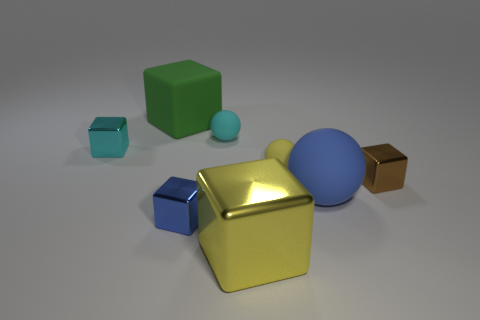Add 2 green cubes. How many objects exist? 10 Subtract all tiny matte balls. How many balls are left? 1 Subtract all spheres. How many objects are left? 5 Add 2 blue rubber things. How many blue rubber things are left? 3 Add 8 cyan metallic blocks. How many cyan metallic blocks exist? 9 Subtract all blue balls. How many balls are left? 2 Subtract 0 yellow cylinders. How many objects are left? 8 Subtract 2 spheres. How many spheres are left? 1 Subtract all cyan spheres. Subtract all yellow cylinders. How many spheres are left? 2 Subtract all purple blocks. How many brown balls are left? 0 